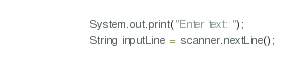Convert code to text. <code><loc_0><loc_0><loc_500><loc_500><_Java_>                    System.out.print("Enter text: ");
                    String inputLine = scanner.nextLine();</code> 